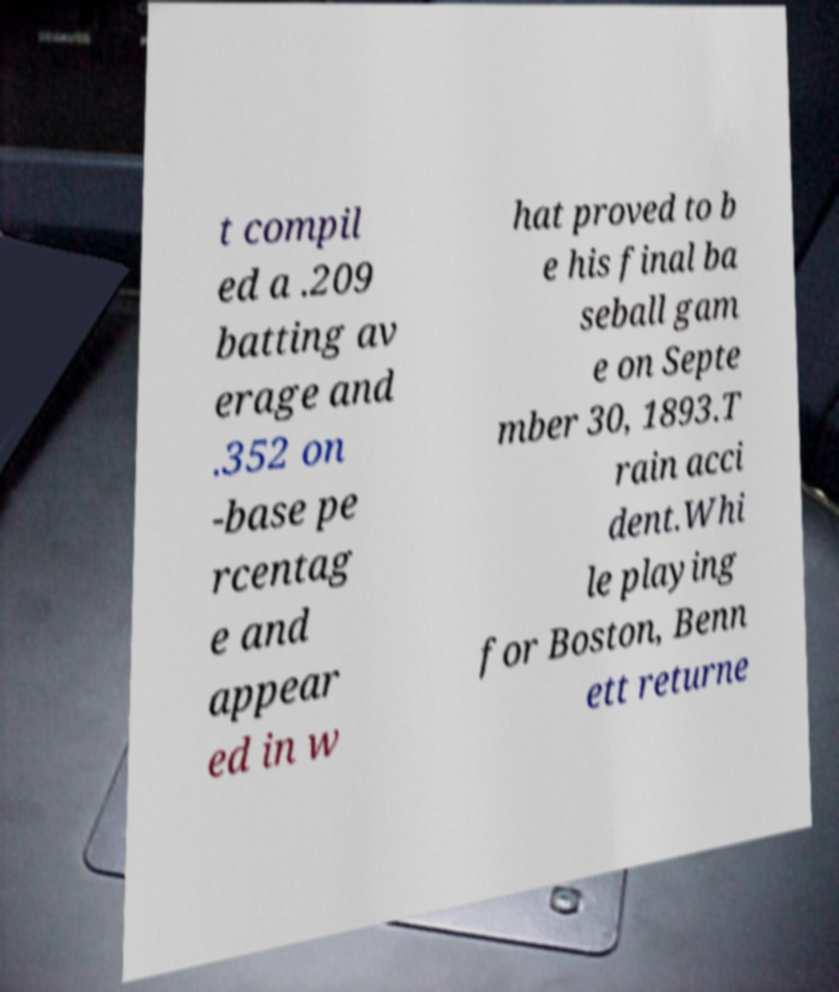I need the written content from this picture converted into text. Can you do that? t compil ed a .209 batting av erage and .352 on -base pe rcentag e and appear ed in w hat proved to b e his final ba seball gam e on Septe mber 30, 1893.T rain acci dent.Whi le playing for Boston, Benn ett returne 